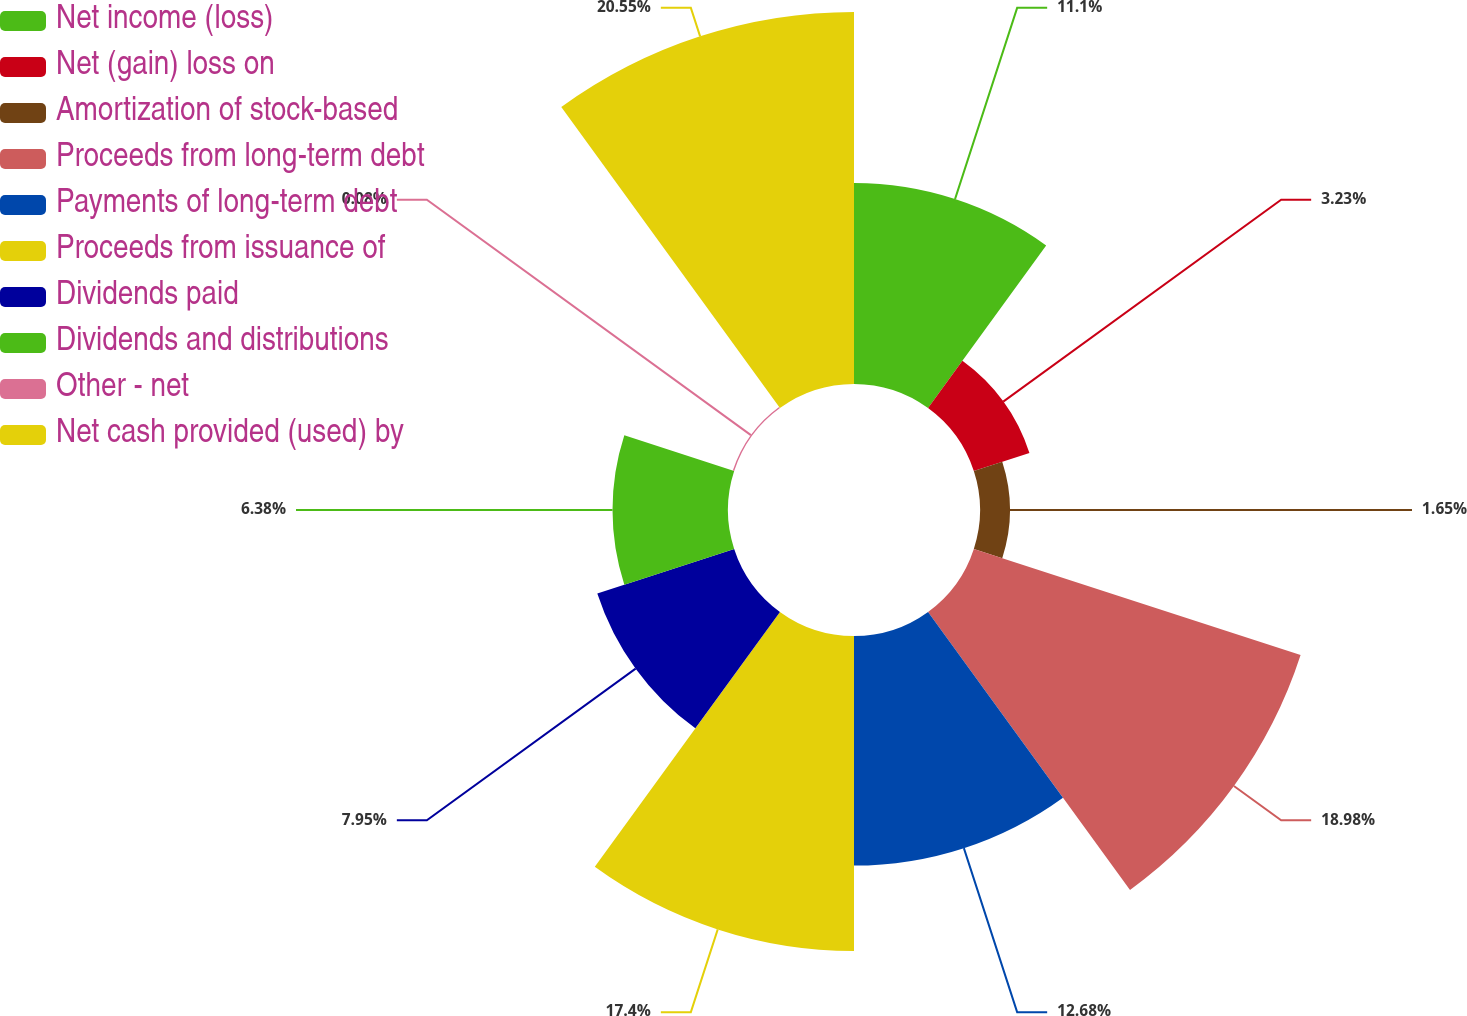<chart> <loc_0><loc_0><loc_500><loc_500><pie_chart><fcel>Net income (loss)<fcel>Net (gain) loss on<fcel>Amortization of stock-based<fcel>Proceeds from long-term debt<fcel>Payments of long-term debt<fcel>Proceeds from issuance of<fcel>Dividends paid<fcel>Dividends and distributions<fcel>Other - net<fcel>Net cash provided (used) by<nl><fcel>11.1%<fcel>3.23%<fcel>1.65%<fcel>18.98%<fcel>12.68%<fcel>17.4%<fcel>7.95%<fcel>6.38%<fcel>0.08%<fcel>20.55%<nl></chart> 